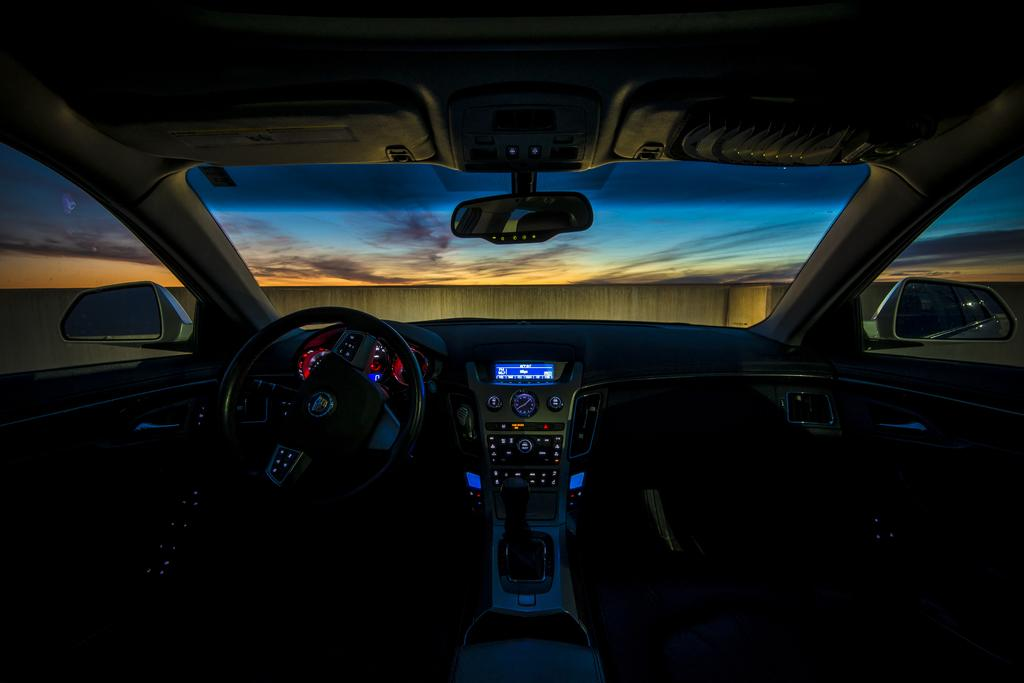What type of space is depicted in the image? The image shows the inside of a vehicle. What is the primary control mechanism in the vehicle? There is a steering wheel in the vehicle. How can the driver monitor their speed in the vehicle? There are speedometers in the vehicle. What feature helps the driver see behind and to the sides of the vehicle? There are mirrors in the vehicle. What device is used to clear the windscreen during rain or snow? There is a windscreen wiper in the vehicle. What can be seen through the windscreen wiper? A wall and the sky are visible through the windscreen wiper. Where is the twig located in the image? There is no twig present in the image. How many passengers are visible in the image? The image only shows the interior of the vehicle, so it is impossible to determine the number of passengers. Is there a bird's nest visible in the image? There is no bird's nest present in the image. 